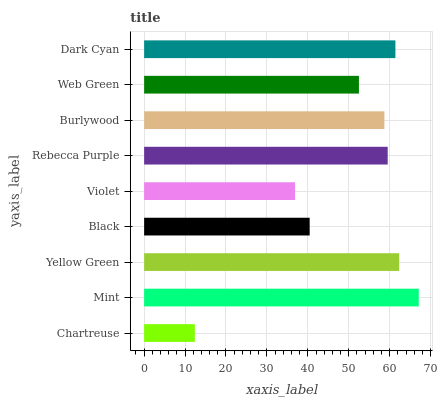Is Chartreuse the minimum?
Answer yes or no. Yes. Is Mint the maximum?
Answer yes or no. Yes. Is Yellow Green the minimum?
Answer yes or no. No. Is Yellow Green the maximum?
Answer yes or no. No. Is Mint greater than Yellow Green?
Answer yes or no. Yes. Is Yellow Green less than Mint?
Answer yes or no. Yes. Is Yellow Green greater than Mint?
Answer yes or no. No. Is Mint less than Yellow Green?
Answer yes or no. No. Is Burlywood the high median?
Answer yes or no. Yes. Is Burlywood the low median?
Answer yes or no. Yes. Is Mint the high median?
Answer yes or no. No. Is Black the low median?
Answer yes or no. No. 